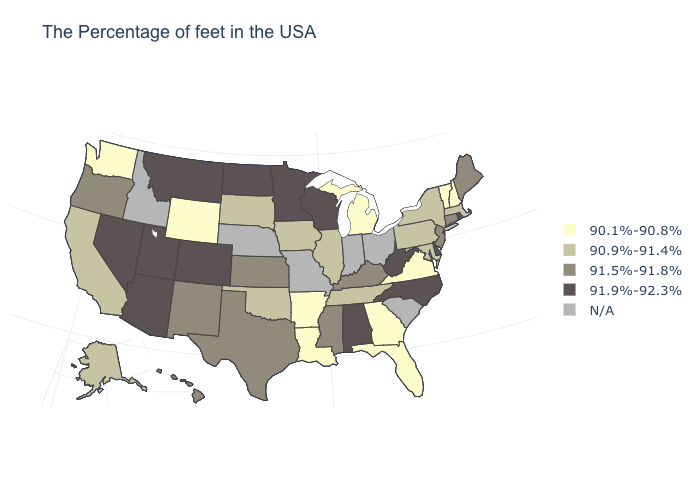Name the states that have a value in the range 90.1%-90.8%?
Write a very short answer. New Hampshire, Vermont, Virginia, Florida, Georgia, Michigan, Louisiana, Arkansas, Wyoming, Washington. Among the states that border Massachusetts , which have the lowest value?
Concise answer only. New Hampshire, Vermont. Is the legend a continuous bar?
Answer briefly. No. What is the lowest value in states that border Texas?
Short answer required. 90.1%-90.8%. What is the value of Arkansas?
Quick response, please. 90.1%-90.8%. Does Hawaii have the highest value in the USA?
Concise answer only. No. What is the highest value in states that border Texas?
Answer briefly. 91.5%-91.8%. Does Minnesota have the highest value in the MidWest?
Give a very brief answer. Yes. Which states hav the highest value in the Northeast?
Answer briefly. Rhode Island. Does the map have missing data?
Be succinct. Yes. What is the highest value in the USA?
Keep it brief. 91.9%-92.3%. What is the lowest value in the West?
Answer briefly. 90.1%-90.8%. What is the highest value in the USA?
Answer briefly. 91.9%-92.3%. What is the lowest value in states that border Washington?
Be succinct. 91.5%-91.8%. 